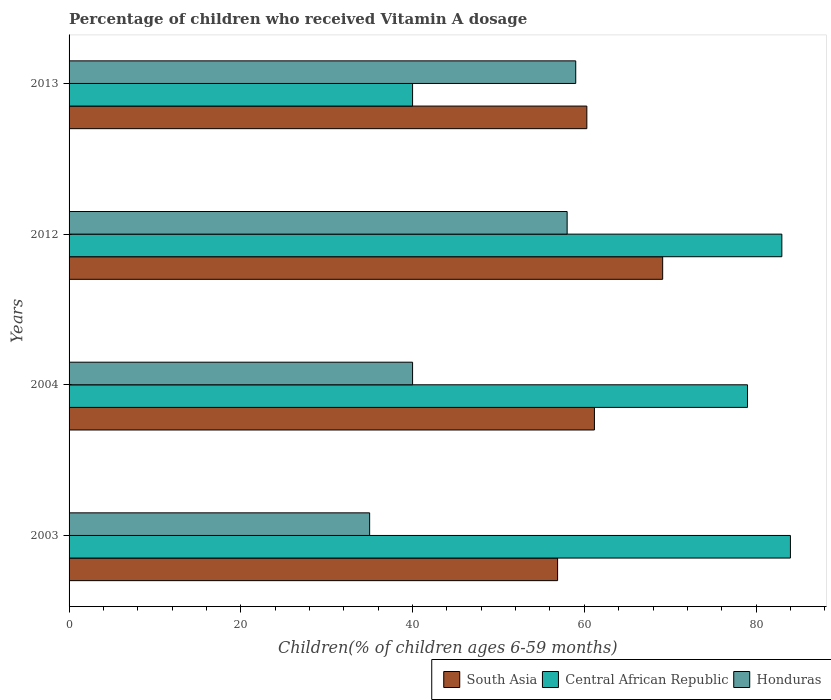How many groups of bars are there?
Provide a short and direct response. 4. Are the number of bars on each tick of the Y-axis equal?
Your response must be concise. Yes. In how many cases, is the number of bars for a given year not equal to the number of legend labels?
Your answer should be very brief. 0. Across all years, what is the minimum percentage of children who received Vitamin A dosage in Central African Republic?
Make the answer very short. 40. What is the total percentage of children who received Vitamin A dosage in Central African Republic in the graph?
Ensure brevity in your answer.  286. What is the difference between the percentage of children who received Vitamin A dosage in Central African Republic in 2003 and the percentage of children who received Vitamin A dosage in South Asia in 2012?
Your answer should be compact. 14.88. In the year 2003, what is the difference between the percentage of children who received Vitamin A dosage in Honduras and percentage of children who received Vitamin A dosage in South Asia?
Provide a succinct answer. -21.89. What is the ratio of the percentage of children who received Vitamin A dosage in South Asia in 2003 to that in 2004?
Make the answer very short. 0.93. Is the percentage of children who received Vitamin A dosage in Central African Republic in 2004 less than that in 2013?
Provide a short and direct response. No. What is the difference between the highest and the second highest percentage of children who received Vitamin A dosage in South Asia?
Ensure brevity in your answer.  7.95. What is the difference between the highest and the lowest percentage of children who received Vitamin A dosage in South Asia?
Offer a very short reply. 12.24. Is the sum of the percentage of children who received Vitamin A dosage in South Asia in 2003 and 2004 greater than the maximum percentage of children who received Vitamin A dosage in Honduras across all years?
Provide a short and direct response. Yes. What does the 2nd bar from the top in 2012 represents?
Your answer should be very brief. Central African Republic. What is the difference between two consecutive major ticks on the X-axis?
Offer a very short reply. 20. Does the graph contain any zero values?
Your answer should be compact. No. Where does the legend appear in the graph?
Provide a short and direct response. Bottom right. What is the title of the graph?
Offer a terse response. Percentage of children who received Vitamin A dosage. Does "Venezuela" appear as one of the legend labels in the graph?
Offer a very short reply. No. What is the label or title of the X-axis?
Your response must be concise. Children(% of children ages 6-59 months). What is the Children(% of children ages 6-59 months) in South Asia in 2003?
Offer a terse response. 56.89. What is the Children(% of children ages 6-59 months) of Central African Republic in 2003?
Keep it short and to the point. 84. What is the Children(% of children ages 6-59 months) in Honduras in 2003?
Your response must be concise. 35. What is the Children(% of children ages 6-59 months) of South Asia in 2004?
Ensure brevity in your answer.  61.18. What is the Children(% of children ages 6-59 months) in Central African Republic in 2004?
Provide a succinct answer. 79. What is the Children(% of children ages 6-59 months) of South Asia in 2012?
Make the answer very short. 69.12. What is the Children(% of children ages 6-59 months) in Central African Republic in 2012?
Your response must be concise. 83. What is the Children(% of children ages 6-59 months) of South Asia in 2013?
Provide a short and direct response. 60.29. What is the Children(% of children ages 6-59 months) in Central African Republic in 2013?
Provide a short and direct response. 40. Across all years, what is the maximum Children(% of children ages 6-59 months) in South Asia?
Make the answer very short. 69.12. Across all years, what is the maximum Children(% of children ages 6-59 months) of Honduras?
Give a very brief answer. 59. Across all years, what is the minimum Children(% of children ages 6-59 months) in South Asia?
Keep it short and to the point. 56.89. What is the total Children(% of children ages 6-59 months) of South Asia in the graph?
Offer a very short reply. 247.48. What is the total Children(% of children ages 6-59 months) in Central African Republic in the graph?
Your response must be concise. 286. What is the total Children(% of children ages 6-59 months) of Honduras in the graph?
Provide a succinct answer. 192. What is the difference between the Children(% of children ages 6-59 months) in South Asia in 2003 and that in 2004?
Make the answer very short. -4.29. What is the difference between the Children(% of children ages 6-59 months) in South Asia in 2003 and that in 2012?
Provide a succinct answer. -12.24. What is the difference between the Children(% of children ages 6-59 months) of Central African Republic in 2003 and that in 2012?
Your answer should be very brief. 1. What is the difference between the Children(% of children ages 6-59 months) in Honduras in 2003 and that in 2012?
Make the answer very short. -23. What is the difference between the Children(% of children ages 6-59 months) in South Asia in 2003 and that in 2013?
Ensure brevity in your answer.  -3.41. What is the difference between the Children(% of children ages 6-59 months) of Honduras in 2003 and that in 2013?
Your answer should be very brief. -24. What is the difference between the Children(% of children ages 6-59 months) of South Asia in 2004 and that in 2012?
Keep it short and to the point. -7.95. What is the difference between the Children(% of children ages 6-59 months) in Honduras in 2004 and that in 2012?
Keep it short and to the point. -18. What is the difference between the Children(% of children ages 6-59 months) in South Asia in 2004 and that in 2013?
Your answer should be very brief. 0.88. What is the difference between the Children(% of children ages 6-59 months) of Central African Republic in 2004 and that in 2013?
Keep it short and to the point. 39. What is the difference between the Children(% of children ages 6-59 months) of South Asia in 2012 and that in 2013?
Offer a very short reply. 8.83. What is the difference between the Children(% of children ages 6-59 months) of South Asia in 2003 and the Children(% of children ages 6-59 months) of Central African Republic in 2004?
Ensure brevity in your answer.  -22.11. What is the difference between the Children(% of children ages 6-59 months) of South Asia in 2003 and the Children(% of children ages 6-59 months) of Honduras in 2004?
Your answer should be very brief. 16.89. What is the difference between the Children(% of children ages 6-59 months) of South Asia in 2003 and the Children(% of children ages 6-59 months) of Central African Republic in 2012?
Offer a terse response. -26.11. What is the difference between the Children(% of children ages 6-59 months) in South Asia in 2003 and the Children(% of children ages 6-59 months) in Honduras in 2012?
Your response must be concise. -1.11. What is the difference between the Children(% of children ages 6-59 months) in Central African Republic in 2003 and the Children(% of children ages 6-59 months) in Honduras in 2012?
Make the answer very short. 26. What is the difference between the Children(% of children ages 6-59 months) of South Asia in 2003 and the Children(% of children ages 6-59 months) of Central African Republic in 2013?
Keep it short and to the point. 16.89. What is the difference between the Children(% of children ages 6-59 months) of South Asia in 2003 and the Children(% of children ages 6-59 months) of Honduras in 2013?
Give a very brief answer. -2.11. What is the difference between the Children(% of children ages 6-59 months) of Central African Republic in 2003 and the Children(% of children ages 6-59 months) of Honduras in 2013?
Offer a terse response. 25. What is the difference between the Children(% of children ages 6-59 months) of South Asia in 2004 and the Children(% of children ages 6-59 months) of Central African Republic in 2012?
Give a very brief answer. -21.82. What is the difference between the Children(% of children ages 6-59 months) of South Asia in 2004 and the Children(% of children ages 6-59 months) of Honduras in 2012?
Provide a succinct answer. 3.18. What is the difference between the Children(% of children ages 6-59 months) of South Asia in 2004 and the Children(% of children ages 6-59 months) of Central African Republic in 2013?
Give a very brief answer. 21.18. What is the difference between the Children(% of children ages 6-59 months) of South Asia in 2004 and the Children(% of children ages 6-59 months) of Honduras in 2013?
Provide a short and direct response. 2.18. What is the difference between the Children(% of children ages 6-59 months) of Central African Republic in 2004 and the Children(% of children ages 6-59 months) of Honduras in 2013?
Offer a terse response. 20. What is the difference between the Children(% of children ages 6-59 months) in South Asia in 2012 and the Children(% of children ages 6-59 months) in Central African Republic in 2013?
Give a very brief answer. 29.12. What is the difference between the Children(% of children ages 6-59 months) of South Asia in 2012 and the Children(% of children ages 6-59 months) of Honduras in 2013?
Provide a succinct answer. 10.12. What is the difference between the Children(% of children ages 6-59 months) of Central African Republic in 2012 and the Children(% of children ages 6-59 months) of Honduras in 2013?
Make the answer very short. 24. What is the average Children(% of children ages 6-59 months) of South Asia per year?
Your answer should be very brief. 61.87. What is the average Children(% of children ages 6-59 months) of Central African Republic per year?
Ensure brevity in your answer.  71.5. What is the average Children(% of children ages 6-59 months) of Honduras per year?
Make the answer very short. 48. In the year 2003, what is the difference between the Children(% of children ages 6-59 months) in South Asia and Children(% of children ages 6-59 months) in Central African Republic?
Your response must be concise. -27.11. In the year 2003, what is the difference between the Children(% of children ages 6-59 months) in South Asia and Children(% of children ages 6-59 months) in Honduras?
Your answer should be compact. 21.89. In the year 2004, what is the difference between the Children(% of children ages 6-59 months) of South Asia and Children(% of children ages 6-59 months) of Central African Republic?
Your answer should be compact. -17.82. In the year 2004, what is the difference between the Children(% of children ages 6-59 months) of South Asia and Children(% of children ages 6-59 months) of Honduras?
Provide a short and direct response. 21.18. In the year 2012, what is the difference between the Children(% of children ages 6-59 months) of South Asia and Children(% of children ages 6-59 months) of Central African Republic?
Make the answer very short. -13.88. In the year 2012, what is the difference between the Children(% of children ages 6-59 months) of South Asia and Children(% of children ages 6-59 months) of Honduras?
Offer a terse response. 11.12. In the year 2013, what is the difference between the Children(% of children ages 6-59 months) of South Asia and Children(% of children ages 6-59 months) of Central African Republic?
Provide a short and direct response. 20.29. In the year 2013, what is the difference between the Children(% of children ages 6-59 months) in South Asia and Children(% of children ages 6-59 months) in Honduras?
Ensure brevity in your answer.  1.29. In the year 2013, what is the difference between the Children(% of children ages 6-59 months) in Central African Republic and Children(% of children ages 6-59 months) in Honduras?
Ensure brevity in your answer.  -19. What is the ratio of the Children(% of children ages 6-59 months) in South Asia in 2003 to that in 2004?
Offer a very short reply. 0.93. What is the ratio of the Children(% of children ages 6-59 months) in Central African Republic in 2003 to that in 2004?
Your answer should be very brief. 1.06. What is the ratio of the Children(% of children ages 6-59 months) of Honduras in 2003 to that in 2004?
Provide a short and direct response. 0.88. What is the ratio of the Children(% of children ages 6-59 months) of South Asia in 2003 to that in 2012?
Provide a succinct answer. 0.82. What is the ratio of the Children(% of children ages 6-59 months) of Central African Republic in 2003 to that in 2012?
Provide a succinct answer. 1.01. What is the ratio of the Children(% of children ages 6-59 months) in Honduras in 2003 to that in 2012?
Your answer should be very brief. 0.6. What is the ratio of the Children(% of children ages 6-59 months) in South Asia in 2003 to that in 2013?
Your response must be concise. 0.94. What is the ratio of the Children(% of children ages 6-59 months) of Central African Republic in 2003 to that in 2013?
Make the answer very short. 2.1. What is the ratio of the Children(% of children ages 6-59 months) of Honduras in 2003 to that in 2013?
Ensure brevity in your answer.  0.59. What is the ratio of the Children(% of children ages 6-59 months) in South Asia in 2004 to that in 2012?
Offer a very short reply. 0.89. What is the ratio of the Children(% of children ages 6-59 months) of Central African Republic in 2004 to that in 2012?
Provide a succinct answer. 0.95. What is the ratio of the Children(% of children ages 6-59 months) of Honduras in 2004 to that in 2012?
Offer a terse response. 0.69. What is the ratio of the Children(% of children ages 6-59 months) in South Asia in 2004 to that in 2013?
Keep it short and to the point. 1.01. What is the ratio of the Children(% of children ages 6-59 months) in Central African Republic in 2004 to that in 2013?
Provide a short and direct response. 1.98. What is the ratio of the Children(% of children ages 6-59 months) of Honduras in 2004 to that in 2013?
Provide a succinct answer. 0.68. What is the ratio of the Children(% of children ages 6-59 months) in South Asia in 2012 to that in 2013?
Offer a very short reply. 1.15. What is the ratio of the Children(% of children ages 6-59 months) in Central African Republic in 2012 to that in 2013?
Your answer should be very brief. 2.08. What is the ratio of the Children(% of children ages 6-59 months) in Honduras in 2012 to that in 2013?
Offer a very short reply. 0.98. What is the difference between the highest and the second highest Children(% of children ages 6-59 months) of South Asia?
Your answer should be very brief. 7.95. What is the difference between the highest and the lowest Children(% of children ages 6-59 months) of South Asia?
Provide a short and direct response. 12.24. What is the difference between the highest and the lowest Children(% of children ages 6-59 months) of Honduras?
Ensure brevity in your answer.  24. 